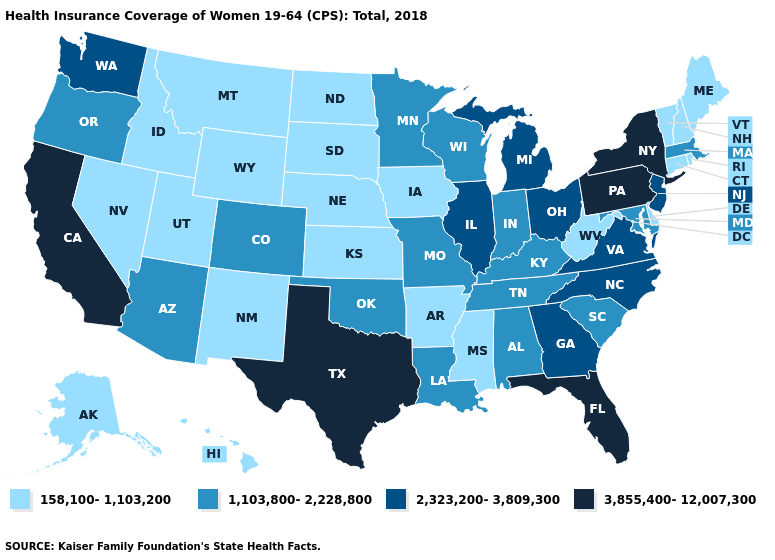Name the states that have a value in the range 158,100-1,103,200?
Give a very brief answer. Alaska, Arkansas, Connecticut, Delaware, Hawaii, Idaho, Iowa, Kansas, Maine, Mississippi, Montana, Nebraska, Nevada, New Hampshire, New Mexico, North Dakota, Rhode Island, South Dakota, Utah, Vermont, West Virginia, Wyoming. Does the map have missing data?
Concise answer only. No. Which states hav the highest value in the South?
Give a very brief answer. Florida, Texas. How many symbols are there in the legend?
Keep it brief. 4. What is the value of Ohio?
Concise answer only. 2,323,200-3,809,300. Name the states that have a value in the range 158,100-1,103,200?
Quick response, please. Alaska, Arkansas, Connecticut, Delaware, Hawaii, Idaho, Iowa, Kansas, Maine, Mississippi, Montana, Nebraska, Nevada, New Hampshire, New Mexico, North Dakota, Rhode Island, South Dakota, Utah, Vermont, West Virginia, Wyoming. Among the states that border Utah , does Colorado have the lowest value?
Concise answer only. No. Which states have the lowest value in the South?
Concise answer only. Arkansas, Delaware, Mississippi, West Virginia. What is the value of South Dakota?
Concise answer only. 158,100-1,103,200. Name the states that have a value in the range 3,855,400-12,007,300?
Write a very short answer. California, Florida, New York, Pennsylvania, Texas. Does the map have missing data?
Be succinct. No. What is the value of New Jersey?
Write a very short answer. 2,323,200-3,809,300. Does the map have missing data?
Quick response, please. No. What is the value of Minnesota?
Quick response, please. 1,103,800-2,228,800. Does Washington have the highest value in the West?
Write a very short answer. No. 